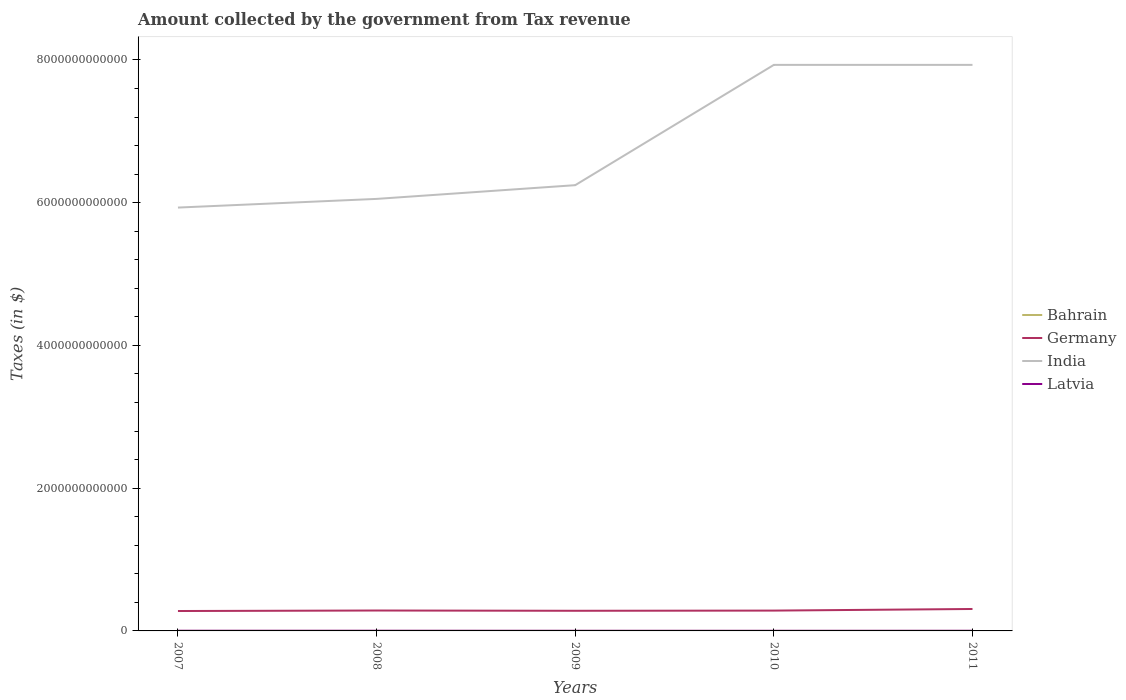How many different coloured lines are there?
Make the answer very short. 4. Across all years, what is the maximum amount collected by the government from tax revenue in Germany?
Your answer should be very brief. 2.79e+11. What is the total amount collected by the government from tax revenue in Latvia in the graph?
Your answer should be very brief. 4.32e+08. What is the difference between the highest and the second highest amount collected by the government from tax revenue in Latvia?
Your response must be concise. 8.03e+08. What is the difference between the highest and the lowest amount collected by the government from tax revenue in Germany?
Give a very brief answer. 1. How many lines are there?
Your answer should be very brief. 4. How many years are there in the graph?
Give a very brief answer. 5. What is the difference between two consecutive major ticks on the Y-axis?
Give a very brief answer. 2.00e+12. Are the values on the major ticks of Y-axis written in scientific E-notation?
Offer a very short reply. No. Where does the legend appear in the graph?
Your response must be concise. Center right. How many legend labels are there?
Make the answer very short. 4. What is the title of the graph?
Your response must be concise. Amount collected by the government from Tax revenue. What is the label or title of the Y-axis?
Make the answer very short. Taxes (in $). What is the Taxes (in $) of Bahrain in 2007?
Your answer should be compact. 9.36e+07. What is the Taxes (in $) of Germany in 2007?
Keep it short and to the point. 2.79e+11. What is the Taxes (in $) of India in 2007?
Make the answer very short. 5.93e+12. What is the Taxes (in $) of Latvia in 2007?
Make the answer very short. 2.31e+09. What is the Taxes (in $) of Bahrain in 2008?
Your answer should be very brief. 1.19e+08. What is the Taxes (in $) in Germany in 2008?
Your response must be concise. 2.86e+11. What is the Taxes (in $) in India in 2008?
Your answer should be very brief. 6.05e+12. What is the Taxes (in $) in Latvia in 2008?
Keep it short and to the point. 2.43e+09. What is the Taxes (in $) in Bahrain in 2009?
Provide a short and direct response. 1.18e+08. What is the Taxes (in $) in Germany in 2009?
Provide a succinct answer. 2.82e+11. What is the Taxes (in $) in India in 2009?
Keep it short and to the point. 6.25e+12. What is the Taxes (in $) of Latvia in 2009?
Give a very brief answer. 1.75e+09. What is the Taxes (in $) of Bahrain in 2010?
Give a very brief answer. 1.14e+08. What is the Taxes (in $) of Germany in 2010?
Give a very brief answer. 2.85e+11. What is the Taxes (in $) of India in 2010?
Keep it short and to the point. 7.93e+12. What is the Taxes (in $) of Latvia in 2010?
Provide a short and direct response. 1.63e+09. What is the Taxes (in $) in Bahrain in 2011?
Make the answer very short. 1.21e+08. What is the Taxes (in $) in Germany in 2011?
Give a very brief answer. 3.07e+11. What is the Taxes (in $) of India in 2011?
Offer a very short reply. 7.93e+12. What is the Taxes (in $) in Latvia in 2011?
Ensure brevity in your answer.  1.88e+09. Across all years, what is the maximum Taxes (in $) in Bahrain?
Provide a short and direct response. 1.21e+08. Across all years, what is the maximum Taxes (in $) in Germany?
Provide a short and direct response. 3.07e+11. Across all years, what is the maximum Taxes (in $) of India?
Ensure brevity in your answer.  7.93e+12. Across all years, what is the maximum Taxes (in $) in Latvia?
Offer a very short reply. 2.43e+09. Across all years, what is the minimum Taxes (in $) in Bahrain?
Offer a terse response. 9.36e+07. Across all years, what is the minimum Taxes (in $) in Germany?
Your answer should be very brief. 2.79e+11. Across all years, what is the minimum Taxes (in $) in India?
Provide a succinct answer. 5.93e+12. Across all years, what is the minimum Taxes (in $) in Latvia?
Your response must be concise. 1.63e+09. What is the total Taxes (in $) of Bahrain in the graph?
Make the answer very short. 5.65e+08. What is the total Taxes (in $) of Germany in the graph?
Your answer should be compact. 1.44e+12. What is the total Taxes (in $) in India in the graph?
Your response must be concise. 3.41e+13. What is the total Taxes (in $) of Latvia in the graph?
Give a very brief answer. 1.00e+1. What is the difference between the Taxes (in $) in Bahrain in 2007 and that in 2008?
Your response must be concise. -2.59e+07. What is the difference between the Taxes (in $) in Germany in 2007 and that in 2008?
Ensure brevity in your answer.  -6.81e+09. What is the difference between the Taxes (in $) in India in 2007 and that in 2008?
Make the answer very short. -1.22e+11. What is the difference between the Taxes (in $) in Latvia in 2007 and that in 2008?
Your answer should be very brief. -1.18e+08. What is the difference between the Taxes (in $) in Bahrain in 2007 and that in 2009?
Give a very brief answer. -2.40e+07. What is the difference between the Taxes (in $) of Germany in 2007 and that in 2009?
Provide a short and direct response. -3.23e+09. What is the difference between the Taxes (in $) of India in 2007 and that in 2009?
Make the answer very short. -3.14e+11. What is the difference between the Taxes (in $) in Latvia in 2007 and that in 2009?
Your response must be concise. 5.58e+08. What is the difference between the Taxes (in $) of Bahrain in 2007 and that in 2010?
Offer a terse response. -2.02e+07. What is the difference between the Taxes (in $) in Germany in 2007 and that in 2010?
Provide a succinct answer. -5.81e+09. What is the difference between the Taxes (in $) of India in 2007 and that in 2010?
Provide a succinct answer. -2.00e+12. What is the difference between the Taxes (in $) in Latvia in 2007 and that in 2010?
Provide a succinct answer. 6.86e+08. What is the difference between the Taxes (in $) of Bahrain in 2007 and that in 2011?
Give a very brief answer. -2.70e+07. What is the difference between the Taxes (in $) in Germany in 2007 and that in 2011?
Give a very brief answer. -2.84e+1. What is the difference between the Taxes (in $) of India in 2007 and that in 2011?
Offer a terse response. -2.00e+12. What is the difference between the Taxes (in $) of Latvia in 2007 and that in 2011?
Your response must be concise. 4.32e+08. What is the difference between the Taxes (in $) in Bahrain in 2008 and that in 2009?
Ensure brevity in your answer.  1.90e+06. What is the difference between the Taxes (in $) in Germany in 2008 and that in 2009?
Keep it short and to the point. 3.58e+09. What is the difference between the Taxes (in $) of India in 2008 and that in 2009?
Ensure brevity in your answer.  -1.92e+11. What is the difference between the Taxes (in $) of Latvia in 2008 and that in 2009?
Ensure brevity in your answer.  6.76e+08. What is the difference between the Taxes (in $) in Bahrain in 2008 and that in 2010?
Your answer should be compact. 5.75e+06. What is the difference between the Taxes (in $) of India in 2008 and that in 2010?
Ensure brevity in your answer.  -1.88e+12. What is the difference between the Taxes (in $) of Latvia in 2008 and that in 2010?
Make the answer very short. 8.03e+08. What is the difference between the Taxes (in $) of Bahrain in 2008 and that in 2011?
Offer a terse response. -1.08e+06. What is the difference between the Taxes (in $) in Germany in 2008 and that in 2011?
Your answer should be very brief. -2.16e+1. What is the difference between the Taxes (in $) of India in 2008 and that in 2011?
Ensure brevity in your answer.  -1.88e+12. What is the difference between the Taxes (in $) in Latvia in 2008 and that in 2011?
Your answer should be very brief. 5.49e+08. What is the difference between the Taxes (in $) in Bahrain in 2009 and that in 2010?
Make the answer very short. 3.85e+06. What is the difference between the Taxes (in $) in Germany in 2009 and that in 2010?
Offer a terse response. -2.58e+09. What is the difference between the Taxes (in $) of India in 2009 and that in 2010?
Ensure brevity in your answer.  -1.69e+12. What is the difference between the Taxes (in $) of Latvia in 2009 and that in 2010?
Ensure brevity in your answer.  1.28e+08. What is the difference between the Taxes (in $) in Bahrain in 2009 and that in 2011?
Provide a succinct answer. -2.98e+06. What is the difference between the Taxes (in $) in Germany in 2009 and that in 2011?
Your response must be concise. -2.51e+1. What is the difference between the Taxes (in $) in India in 2009 and that in 2011?
Your answer should be very brief. -1.69e+12. What is the difference between the Taxes (in $) of Latvia in 2009 and that in 2011?
Provide a succinct answer. -1.26e+08. What is the difference between the Taxes (in $) in Bahrain in 2010 and that in 2011?
Ensure brevity in your answer.  -6.83e+06. What is the difference between the Taxes (in $) in Germany in 2010 and that in 2011?
Provide a succinct answer. -2.26e+1. What is the difference between the Taxes (in $) of Latvia in 2010 and that in 2011?
Make the answer very short. -2.54e+08. What is the difference between the Taxes (in $) in Bahrain in 2007 and the Taxes (in $) in Germany in 2008?
Offer a terse response. -2.86e+11. What is the difference between the Taxes (in $) of Bahrain in 2007 and the Taxes (in $) of India in 2008?
Offer a very short reply. -6.05e+12. What is the difference between the Taxes (in $) of Bahrain in 2007 and the Taxes (in $) of Latvia in 2008?
Your response must be concise. -2.34e+09. What is the difference between the Taxes (in $) of Germany in 2007 and the Taxes (in $) of India in 2008?
Provide a succinct answer. -5.77e+12. What is the difference between the Taxes (in $) of Germany in 2007 and the Taxes (in $) of Latvia in 2008?
Offer a very short reply. 2.77e+11. What is the difference between the Taxes (in $) of India in 2007 and the Taxes (in $) of Latvia in 2008?
Offer a terse response. 5.93e+12. What is the difference between the Taxes (in $) in Bahrain in 2007 and the Taxes (in $) in Germany in 2009?
Make the answer very short. -2.82e+11. What is the difference between the Taxes (in $) of Bahrain in 2007 and the Taxes (in $) of India in 2009?
Your answer should be compact. -6.25e+12. What is the difference between the Taxes (in $) in Bahrain in 2007 and the Taxes (in $) in Latvia in 2009?
Offer a terse response. -1.66e+09. What is the difference between the Taxes (in $) in Germany in 2007 and the Taxes (in $) in India in 2009?
Your response must be concise. -5.97e+12. What is the difference between the Taxes (in $) in Germany in 2007 and the Taxes (in $) in Latvia in 2009?
Ensure brevity in your answer.  2.77e+11. What is the difference between the Taxes (in $) in India in 2007 and the Taxes (in $) in Latvia in 2009?
Your response must be concise. 5.93e+12. What is the difference between the Taxes (in $) in Bahrain in 2007 and the Taxes (in $) in Germany in 2010?
Provide a short and direct response. -2.85e+11. What is the difference between the Taxes (in $) of Bahrain in 2007 and the Taxes (in $) of India in 2010?
Offer a terse response. -7.93e+12. What is the difference between the Taxes (in $) in Bahrain in 2007 and the Taxes (in $) in Latvia in 2010?
Your answer should be very brief. -1.53e+09. What is the difference between the Taxes (in $) in Germany in 2007 and the Taxes (in $) in India in 2010?
Offer a very short reply. -7.65e+12. What is the difference between the Taxes (in $) of Germany in 2007 and the Taxes (in $) of Latvia in 2010?
Offer a very short reply. 2.77e+11. What is the difference between the Taxes (in $) in India in 2007 and the Taxes (in $) in Latvia in 2010?
Your answer should be compact. 5.93e+12. What is the difference between the Taxes (in $) in Bahrain in 2007 and the Taxes (in $) in Germany in 2011?
Give a very brief answer. -3.07e+11. What is the difference between the Taxes (in $) in Bahrain in 2007 and the Taxes (in $) in India in 2011?
Give a very brief answer. -7.93e+12. What is the difference between the Taxes (in $) in Bahrain in 2007 and the Taxes (in $) in Latvia in 2011?
Your answer should be compact. -1.79e+09. What is the difference between the Taxes (in $) in Germany in 2007 and the Taxes (in $) in India in 2011?
Your answer should be compact. -7.65e+12. What is the difference between the Taxes (in $) of Germany in 2007 and the Taxes (in $) of Latvia in 2011?
Keep it short and to the point. 2.77e+11. What is the difference between the Taxes (in $) of India in 2007 and the Taxes (in $) of Latvia in 2011?
Make the answer very short. 5.93e+12. What is the difference between the Taxes (in $) in Bahrain in 2008 and the Taxes (in $) in Germany in 2009?
Your answer should be very brief. -2.82e+11. What is the difference between the Taxes (in $) in Bahrain in 2008 and the Taxes (in $) in India in 2009?
Give a very brief answer. -6.25e+12. What is the difference between the Taxes (in $) of Bahrain in 2008 and the Taxes (in $) of Latvia in 2009?
Your answer should be compact. -1.63e+09. What is the difference between the Taxes (in $) of Germany in 2008 and the Taxes (in $) of India in 2009?
Your response must be concise. -5.96e+12. What is the difference between the Taxes (in $) of Germany in 2008 and the Taxes (in $) of Latvia in 2009?
Offer a terse response. 2.84e+11. What is the difference between the Taxes (in $) in India in 2008 and the Taxes (in $) in Latvia in 2009?
Provide a short and direct response. 6.05e+12. What is the difference between the Taxes (in $) of Bahrain in 2008 and the Taxes (in $) of Germany in 2010?
Offer a terse response. -2.85e+11. What is the difference between the Taxes (in $) of Bahrain in 2008 and the Taxes (in $) of India in 2010?
Your answer should be compact. -7.93e+12. What is the difference between the Taxes (in $) in Bahrain in 2008 and the Taxes (in $) in Latvia in 2010?
Ensure brevity in your answer.  -1.51e+09. What is the difference between the Taxes (in $) in Germany in 2008 and the Taxes (in $) in India in 2010?
Provide a succinct answer. -7.64e+12. What is the difference between the Taxes (in $) in Germany in 2008 and the Taxes (in $) in Latvia in 2010?
Give a very brief answer. 2.84e+11. What is the difference between the Taxes (in $) in India in 2008 and the Taxes (in $) in Latvia in 2010?
Offer a terse response. 6.05e+12. What is the difference between the Taxes (in $) in Bahrain in 2008 and the Taxes (in $) in Germany in 2011?
Provide a succinct answer. -3.07e+11. What is the difference between the Taxes (in $) in Bahrain in 2008 and the Taxes (in $) in India in 2011?
Make the answer very short. -7.93e+12. What is the difference between the Taxes (in $) of Bahrain in 2008 and the Taxes (in $) of Latvia in 2011?
Your response must be concise. -1.76e+09. What is the difference between the Taxes (in $) of Germany in 2008 and the Taxes (in $) of India in 2011?
Give a very brief answer. -7.64e+12. What is the difference between the Taxes (in $) of Germany in 2008 and the Taxes (in $) of Latvia in 2011?
Provide a succinct answer. 2.84e+11. What is the difference between the Taxes (in $) of India in 2008 and the Taxes (in $) of Latvia in 2011?
Your answer should be very brief. 6.05e+12. What is the difference between the Taxes (in $) in Bahrain in 2009 and the Taxes (in $) in Germany in 2010?
Your answer should be compact. -2.85e+11. What is the difference between the Taxes (in $) in Bahrain in 2009 and the Taxes (in $) in India in 2010?
Your answer should be very brief. -7.93e+12. What is the difference between the Taxes (in $) in Bahrain in 2009 and the Taxes (in $) in Latvia in 2010?
Make the answer very short. -1.51e+09. What is the difference between the Taxes (in $) in Germany in 2009 and the Taxes (in $) in India in 2010?
Provide a succinct answer. -7.65e+12. What is the difference between the Taxes (in $) in Germany in 2009 and the Taxes (in $) in Latvia in 2010?
Your response must be concise. 2.81e+11. What is the difference between the Taxes (in $) in India in 2009 and the Taxes (in $) in Latvia in 2010?
Keep it short and to the point. 6.24e+12. What is the difference between the Taxes (in $) in Bahrain in 2009 and the Taxes (in $) in Germany in 2011?
Give a very brief answer. -3.07e+11. What is the difference between the Taxes (in $) of Bahrain in 2009 and the Taxes (in $) of India in 2011?
Provide a succinct answer. -7.93e+12. What is the difference between the Taxes (in $) in Bahrain in 2009 and the Taxes (in $) in Latvia in 2011?
Provide a succinct answer. -1.76e+09. What is the difference between the Taxes (in $) of Germany in 2009 and the Taxes (in $) of India in 2011?
Offer a terse response. -7.65e+12. What is the difference between the Taxes (in $) of Germany in 2009 and the Taxes (in $) of Latvia in 2011?
Offer a very short reply. 2.80e+11. What is the difference between the Taxes (in $) of India in 2009 and the Taxes (in $) of Latvia in 2011?
Your answer should be compact. 6.24e+12. What is the difference between the Taxes (in $) in Bahrain in 2010 and the Taxes (in $) in Germany in 2011?
Make the answer very short. -3.07e+11. What is the difference between the Taxes (in $) in Bahrain in 2010 and the Taxes (in $) in India in 2011?
Keep it short and to the point. -7.93e+12. What is the difference between the Taxes (in $) of Bahrain in 2010 and the Taxes (in $) of Latvia in 2011?
Keep it short and to the point. -1.77e+09. What is the difference between the Taxes (in $) of Germany in 2010 and the Taxes (in $) of India in 2011?
Your answer should be compact. -7.65e+12. What is the difference between the Taxes (in $) in Germany in 2010 and the Taxes (in $) in Latvia in 2011?
Your response must be concise. 2.83e+11. What is the difference between the Taxes (in $) of India in 2010 and the Taxes (in $) of Latvia in 2011?
Offer a terse response. 7.93e+12. What is the average Taxes (in $) of Bahrain per year?
Provide a short and direct response. 1.13e+08. What is the average Taxes (in $) of Germany per year?
Offer a terse response. 2.88e+11. What is the average Taxes (in $) of India per year?
Your answer should be very brief. 6.82e+12. What is the average Taxes (in $) of Latvia per year?
Make the answer very short. 2.00e+09. In the year 2007, what is the difference between the Taxes (in $) in Bahrain and Taxes (in $) in Germany?
Ensure brevity in your answer.  -2.79e+11. In the year 2007, what is the difference between the Taxes (in $) of Bahrain and Taxes (in $) of India?
Keep it short and to the point. -5.93e+12. In the year 2007, what is the difference between the Taxes (in $) in Bahrain and Taxes (in $) in Latvia?
Provide a succinct answer. -2.22e+09. In the year 2007, what is the difference between the Taxes (in $) in Germany and Taxes (in $) in India?
Provide a succinct answer. -5.65e+12. In the year 2007, what is the difference between the Taxes (in $) in Germany and Taxes (in $) in Latvia?
Provide a succinct answer. 2.77e+11. In the year 2007, what is the difference between the Taxes (in $) in India and Taxes (in $) in Latvia?
Your response must be concise. 5.93e+12. In the year 2008, what is the difference between the Taxes (in $) of Bahrain and Taxes (in $) of Germany?
Offer a very short reply. -2.86e+11. In the year 2008, what is the difference between the Taxes (in $) in Bahrain and Taxes (in $) in India?
Keep it short and to the point. -6.05e+12. In the year 2008, what is the difference between the Taxes (in $) of Bahrain and Taxes (in $) of Latvia?
Make the answer very short. -2.31e+09. In the year 2008, what is the difference between the Taxes (in $) in Germany and Taxes (in $) in India?
Offer a terse response. -5.77e+12. In the year 2008, what is the difference between the Taxes (in $) in Germany and Taxes (in $) in Latvia?
Offer a very short reply. 2.83e+11. In the year 2008, what is the difference between the Taxes (in $) of India and Taxes (in $) of Latvia?
Give a very brief answer. 6.05e+12. In the year 2009, what is the difference between the Taxes (in $) in Bahrain and Taxes (in $) in Germany?
Provide a succinct answer. -2.82e+11. In the year 2009, what is the difference between the Taxes (in $) in Bahrain and Taxes (in $) in India?
Offer a terse response. -6.25e+12. In the year 2009, what is the difference between the Taxes (in $) in Bahrain and Taxes (in $) in Latvia?
Provide a short and direct response. -1.64e+09. In the year 2009, what is the difference between the Taxes (in $) in Germany and Taxes (in $) in India?
Provide a succinct answer. -5.96e+12. In the year 2009, what is the difference between the Taxes (in $) of Germany and Taxes (in $) of Latvia?
Offer a very short reply. 2.80e+11. In the year 2009, what is the difference between the Taxes (in $) in India and Taxes (in $) in Latvia?
Give a very brief answer. 6.24e+12. In the year 2010, what is the difference between the Taxes (in $) in Bahrain and Taxes (in $) in Germany?
Make the answer very short. -2.85e+11. In the year 2010, what is the difference between the Taxes (in $) of Bahrain and Taxes (in $) of India?
Keep it short and to the point. -7.93e+12. In the year 2010, what is the difference between the Taxes (in $) of Bahrain and Taxes (in $) of Latvia?
Your answer should be very brief. -1.51e+09. In the year 2010, what is the difference between the Taxes (in $) in Germany and Taxes (in $) in India?
Make the answer very short. -7.65e+12. In the year 2010, what is the difference between the Taxes (in $) of Germany and Taxes (in $) of Latvia?
Provide a short and direct response. 2.83e+11. In the year 2010, what is the difference between the Taxes (in $) of India and Taxes (in $) of Latvia?
Ensure brevity in your answer.  7.93e+12. In the year 2011, what is the difference between the Taxes (in $) of Bahrain and Taxes (in $) of Germany?
Your response must be concise. -3.07e+11. In the year 2011, what is the difference between the Taxes (in $) in Bahrain and Taxes (in $) in India?
Ensure brevity in your answer.  -7.93e+12. In the year 2011, what is the difference between the Taxes (in $) in Bahrain and Taxes (in $) in Latvia?
Give a very brief answer. -1.76e+09. In the year 2011, what is the difference between the Taxes (in $) in Germany and Taxes (in $) in India?
Provide a succinct answer. -7.62e+12. In the year 2011, what is the difference between the Taxes (in $) in Germany and Taxes (in $) in Latvia?
Offer a very short reply. 3.05e+11. In the year 2011, what is the difference between the Taxes (in $) of India and Taxes (in $) of Latvia?
Give a very brief answer. 7.93e+12. What is the ratio of the Taxes (in $) of Bahrain in 2007 to that in 2008?
Provide a short and direct response. 0.78. What is the ratio of the Taxes (in $) of Germany in 2007 to that in 2008?
Give a very brief answer. 0.98. What is the ratio of the Taxes (in $) of India in 2007 to that in 2008?
Give a very brief answer. 0.98. What is the ratio of the Taxes (in $) in Latvia in 2007 to that in 2008?
Your answer should be compact. 0.95. What is the ratio of the Taxes (in $) of Bahrain in 2007 to that in 2009?
Offer a terse response. 0.8. What is the ratio of the Taxes (in $) in Germany in 2007 to that in 2009?
Your response must be concise. 0.99. What is the ratio of the Taxes (in $) of India in 2007 to that in 2009?
Your answer should be compact. 0.95. What is the ratio of the Taxes (in $) in Latvia in 2007 to that in 2009?
Your answer should be very brief. 1.32. What is the ratio of the Taxes (in $) in Bahrain in 2007 to that in 2010?
Your answer should be very brief. 0.82. What is the ratio of the Taxes (in $) of Germany in 2007 to that in 2010?
Your answer should be compact. 0.98. What is the ratio of the Taxes (in $) in India in 2007 to that in 2010?
Offer a terse response. 0.75. What is the ratio of the Taxes (in $) of Latvia in 2007 to that in 2010?
Ensure brevity in your answer.  1.42. What is the ratio of the Taxes (in $) of Bahrain in 2007 to that in 2011?
Your answer should be compact. 0.78. What is the ratio of the Taxes (in $) of Germany in 2007 to that in 2011?
Your response must be concise. 0.91. What is the ratio of the Taxes (in $) of India in 2007 to that in 2011?
Give a very brief answer. 0.75. What is the ratio of the Taxes (in $) in Latvia in 2007 to that in 2011?
Give a very brief answer. 1.23. What is the ratio of the Taxes (in $) in Bahrain in 2008 to that in 2009?
Keep it short and to the point. 1.02. What is the ratio of the Taxes (in $) of Germany in 2008 to that in 2009?
Offer a terse response. 1.01. What is the ratio of the Taxes (in $) in India in 2008 to that in 2009?
Provide a short and direct response. 0.97. What is the ratio of the Taxes (in $) of Latvia in 2008 to that in 2009?
Offer a terse response. 1.39. What is the ratio of the Taxes (in $) in Bahrain in 2008 to that in 2010?
Your answer should be very brief. 1.05. What is the ratio of the Taxes (in $) of India in 2008 to that in 2010?
Your response must be concise. 0.76. What is the ratio of the Taxes (in $) in Latvia in 2008 to that in 2010?
Make the answer very short. 1.49. What is the ratio of the Taxes (in $) of Bahrain in 2008 to that in 2011?
Your answer should be compact. 0.99. What is the ratio of the Taxes (in $) in Germany in 2008 to that in 2011?
Provide a succinct answer. 0.93. What is the ratio of the Taxes (in $) of India in 2008 to that in 2011?
Your answer should be compact. 0.76. What is the ratio of the Taxes (in $) of Latvia in 2008 to that in 2011?
Offer a very short reply. 1.29. What is the ratio of the Taxes (in $) in Bahrain in 2009 to that in 2010?
Provide a succinct answer. 1.03. What is the ratio of the Taxes (in $) in Germany in 2009 to that in 2010?
Offer a terse response. 0.99. What is the ratio of the Taxes (in $) in India in 2009 to that in 2010?
Your answer should be compact. 0.79. What is the ratio of the Taxes (in $) of Latvia in 2009 to that in 2010?
Offer a terse response. 1.08. What is the ratio of the Taxes (in $) in Bahrain in 2009 to that in 2011?
Ensure brevity in your answer.  0.98. What is the ratio of the Taxes (in $) in Germany in 2009 to that in 2011?
Provide a succinct answer. 0.92. What is the ratio of the Taxes (in $) in India in 2009 to that in 2011?
Give a very brief answer. 0.79. What is the ratio of the Taxes (in $) of Latvia in 2009 to that in 2011?
Your answer should be compact. 0.93. What is the ratio of the Taxes (in $) of Bahrain in 2010 to that in 2011?
Offer a very short reply. 0.94. What is the ratio of the Taxes (in $) of Germany in 2010 to that in 2011?
Your response must be concise. 0.93. What is the ratio of the Taxes (in $) of India in 2010 to that in 2011?
Offer a very short reply. 1. What is the ratio of the Taxes (in $) of Latvia in 2010 to that in 2011?
Keep it short and to the point. 0.86. What is the difference between the highest and the second highest Taxes (in $) of Bahrain?
Provide a succinct answer. 1.08e+06. What is the difference between the highest and the second highest Taxes (in $) of Germany?
Give a very brief answer. 2.16e+1. What is the difference between the highest and the second highest Taxes (in $) in Latvia?
Offer a terse response. 1.18e+08. What is the difference between the highest and the lowest Taxes (in $) in Bahrain?
Provide a short and direct response. 2.70e+07. What is the difference between the highest and the lowest Taxes (in $) of Germany?
Your answer should be compact. 2.84e+1. What is the difference between the highest and the lowest Taxes (in $) of India?
Ensure brevity in your answer.  2.00e+12. What is the difference between the highest and the lowest Taxes (in $) in Latvia?
Provide a succinct answer. 8.03e+08. 